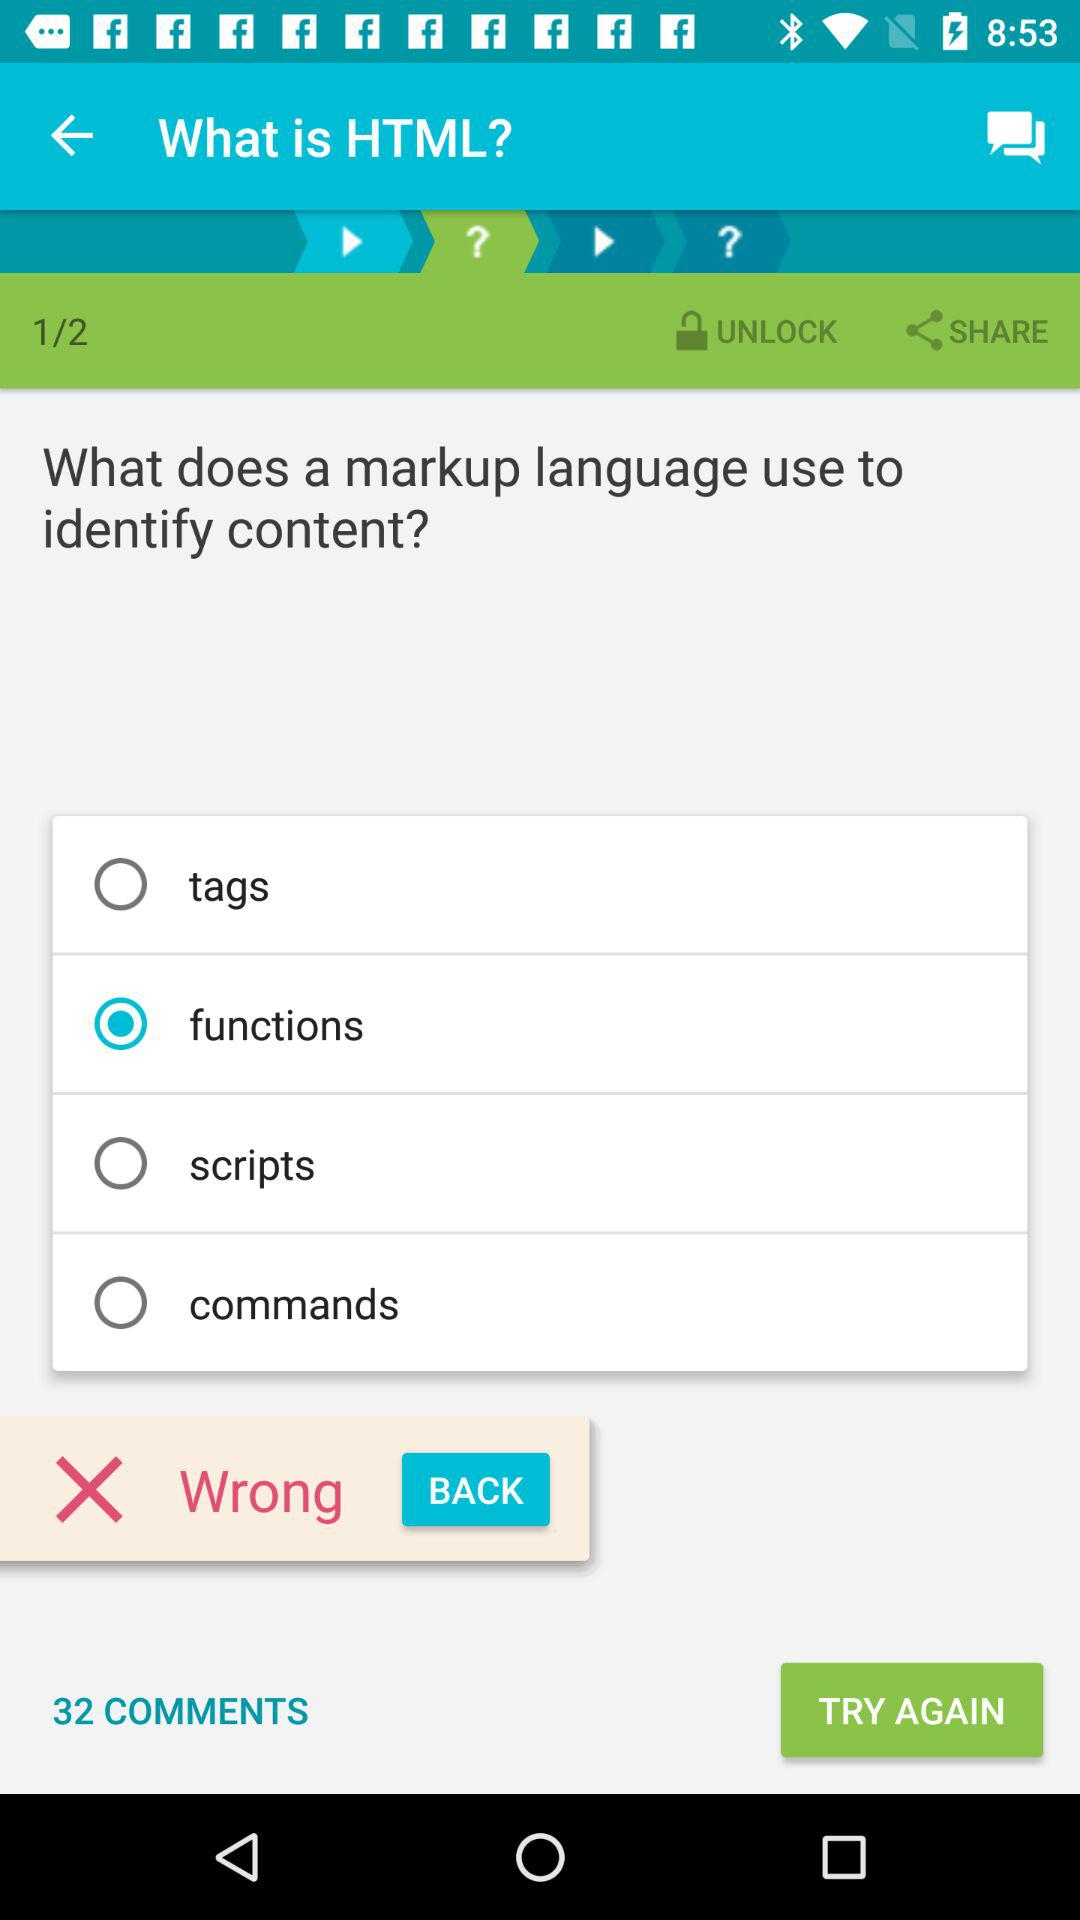What markup language has been mentioned? The mentioned markup language is HTML. 